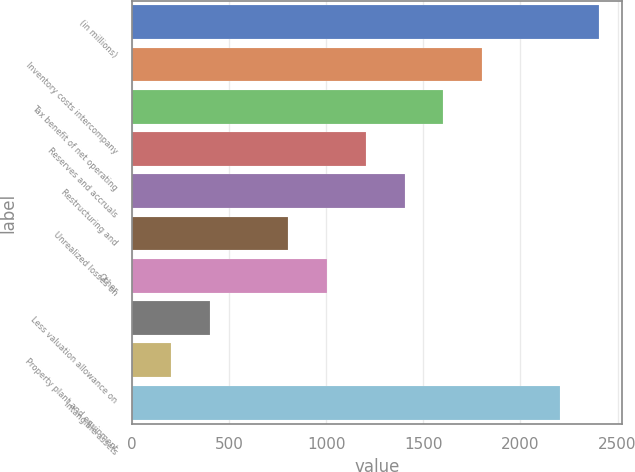Convert chart to OTSL. <chart><loc_0><loc_0><loc_500><loc_500><bar_chart><fcel>(in millions)<fcel>Inventory costs intercompany<fcel>Tax benefit of net operating<fcel>Reserves and accruals<fcel>Restructuring and<fcel>Unrealized losses on<fcel>Other<fcel>Less valuation allowance on<fcel>Property plant and equipment<fcel>Intangible assets<nl><fcel>2404.6<fcel>1803.7<fcel>1603.4<fcel>1202.8<fcel>1403.1<fcel>802.2<fcel>1002.5<fcel>401.6<fcel>201.3<fcel>2204.3<nl></chart> 